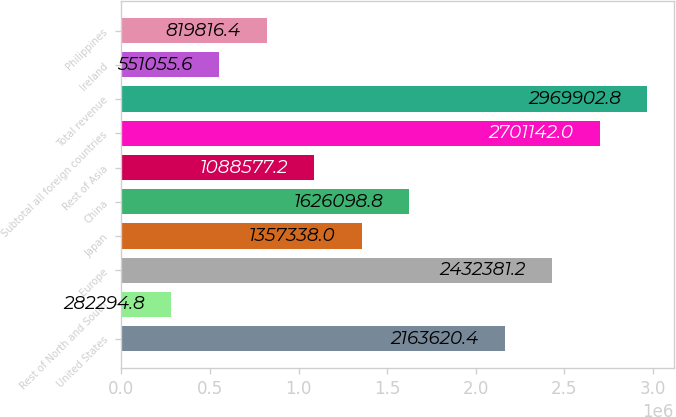Convert chart to OTSL. <chart><loc_0><loc_0><loc_500><loc_500><bar_chart><fcel>United States<fcel>Rest of North and South<fcel>Europe<fcel>Japan<fcel>China<fcel>Rest of Asia<fcel>Subtotal all foreign countries<fcel>Total revenue<fcel>Ireland<fcel>Philippines<nl><fcel>2.16362e+06<fcel>282295<fcel>2.43238e+06<fcel>1.35734e+06<fcel>1.6261e+06<fcel>1.08858e+06<fcel>2.70114e+06<fcel>2.9699e+06<fcel>551056<fcel>819816<nl></chart> 